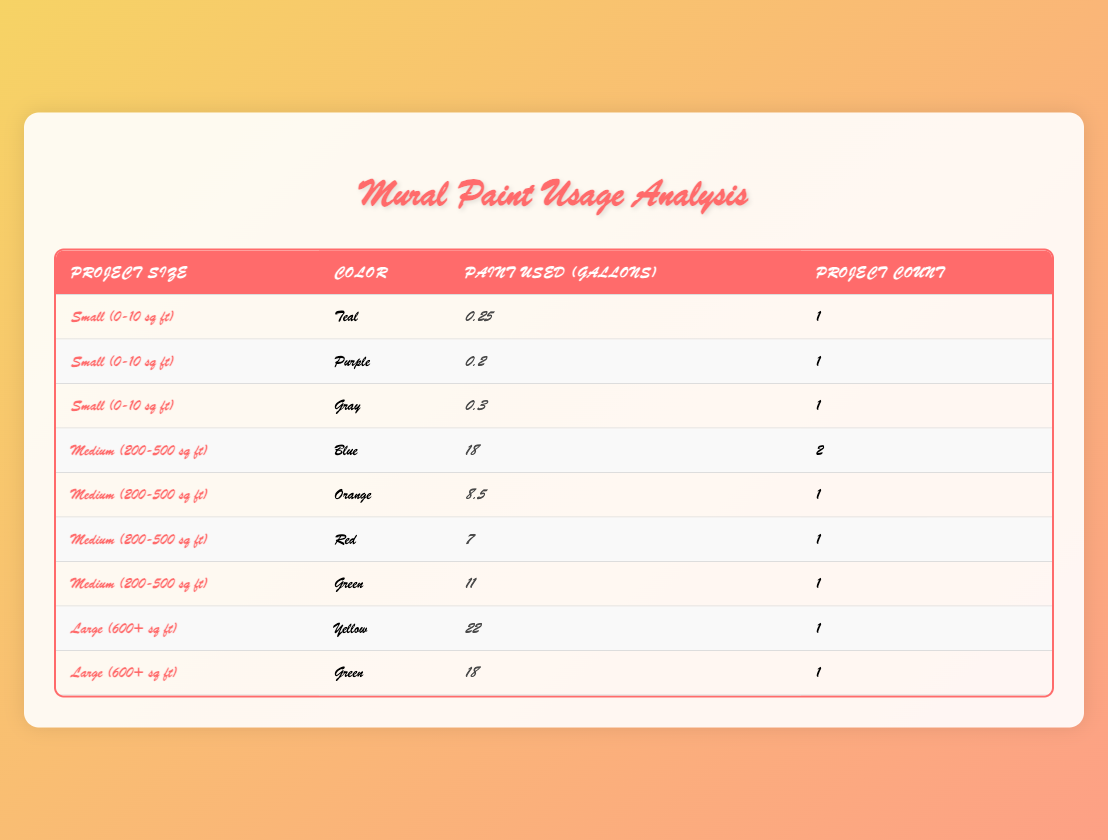What is the total amount of paint used for small projects? In the table, there are three small projects listed. The total paint used for small projects is calculated by adding the paint used in each relevant row: 0.25 (Teal) + 0.2 (Purple) + 0.3 (Gray) = 0.75 gallons.
Answer: 0.75 gallons Which color was used the most in medium projects? Looking at the medium project category, Blue (18 gallons) has the highest amount compared to Orange (8.5 gallons), Red (7 gallons), and Green (11 gallons).
Answer: Blue Is there a project that used Red paint? Yes, the City Hall Entrance project used Red paint and 7 gallons were consumed.
Answer: Yes How many projects used Green paint? In the table, there are two entries for Green paint: one for the Elementary School Playground (18 gallons) and one for the Community Garden Fence (11 gallons). Therefore, the total number of projects using Green paint is 2.
Answer: 2 What is the average amount of paint used per project in large projects? There are two large projects listed: Yellow (22 gallons) and Green (18 gallons). To find the average, add the gallons (22 + 18 = 40) and divide by the number of projects (40 / 2 = 20).
Answer: 20 gallons Which paint brand was used for the project with the largest size? The Downtown Alley Revitalization project is the largest, measuring 800 square feet, and it used Behr paint.
Answer: Behr Was the amount of paint used for the Blue projects greater than the amount used for the Green projects? For Blue projects, the total is 12.5 gallons from the Community Center Mural and 5.5 gallons from the Local Theater Backdrop, totaling 18 gallons. For Green projects, the total is 18 gallons (Elementary School Playground) and 11 gallons (Community Garden Fence), totaling 29 gallons. Since 18 gallons (Blue) is less than 29 gallons (Green), the statement is false.
Answer: No How many different colors are used in the medium-sized projects? The medium-sized projects show four different colors: Blue, Orange, Red, and Green, meaning there are 4 unique color entries.
Answer: 4 What is the total paint used for all projects? To find the total amount of paint used across all projects, we must add up all the paint used: 12.5 + 0.25 + 22 + 18 + 8.5 + 0.2 + 7 + 11 + 0.3 + 5.5 = 85.3 gallons.
Answer: 85.3 gallons 